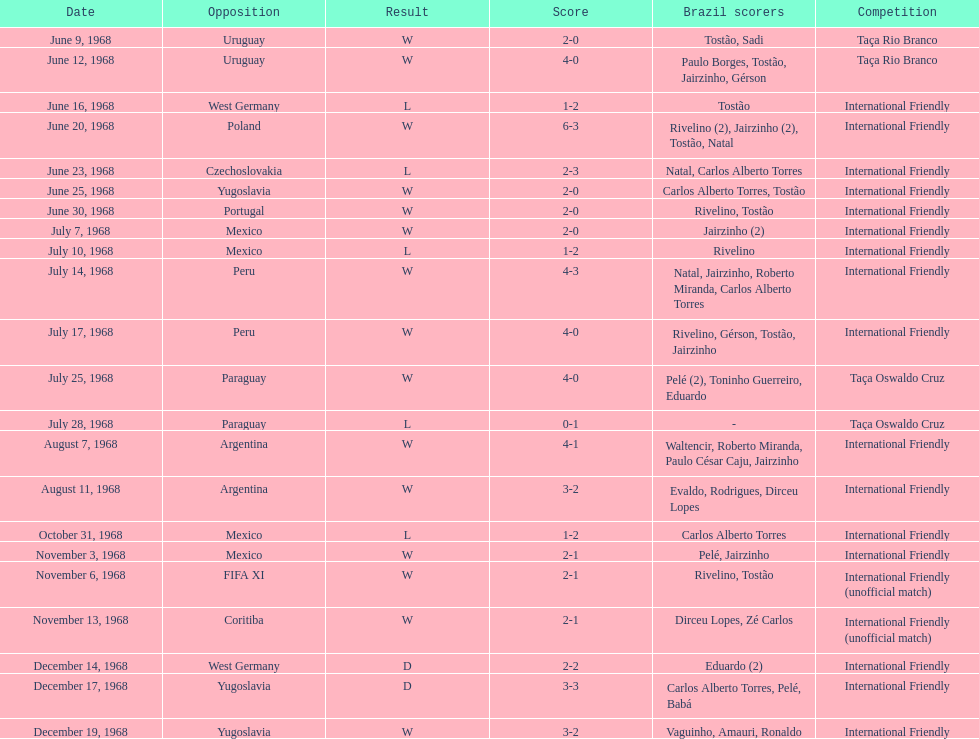What was the first tournament that brazil participated in? Taça Rio Branco. I'm looking to parse the entire table for insights. Could you assist me with that? {'header': ['Date', 'Opposition', 'Result', 'Score', 'Brazil scorers', 'Competition'], 'rows': [['June 9, 1968', 'Uruguay', 'W', '2-0', 'Tostão, Sadi', 'Taça Rio Branco'], ['June 12, 1968', 'Uruguay', 'W', '4-0', 'Paulo Borges, Tostão, Jairzinho, Gérson', 'Taça Rio Branco'], ['June 16, 1968', 'West Germany', 'L', '1-2', 'Tostão', 'International Friendly'], ['June 20, 1968', 'Poland', 'W', '6-3', 'Rivelino (2), Jairzinho (2), Tostão, Natal', 'International Friendly'], ['June 23, 1968', 'Czechoslovakia', 'L', '2-3', 'Natal, Carlos Alberto Torres', 'International Friendly'], ['June 25, 1968', 'Yugoslavia', 'W', '2-0', 'Carlos Alberto Torres, Tostão', 'International Friendly'], ['June 30, 1968', 'Portugal', 'W', '2-0', 'Rivelino, Tostão', 'International Friendly'], ['July 7, 1968', 'Mexico', 'W', '2-0', 'Jairzinho (2)', 'International Friendly'], ['July 10, 1968', 'Mexico', 'L', '1-2', 'Rivelino', 'International Friendly'], ['July 14, 1968', 'Peru', 'W', '4-3', 'Natal, Jairzinho, Roberto Miranda, Carlos Alberto Torres', 'International Friendly'], ['July 17, 1968', 'Peru', 'W', '4-0', 'Rivelino, Gérson, Tostão, Jairzinho', 'International Friendly'], ['July 25, 1968', 'Paraguay', 'W', '4-0', 'Pelé (2), Toninho Guerreiro, Eduardo', 'Taça Oswaldo Cruz'], ['July 28, 1968', 'Paraguay', 'L', '0-1', '-', 'Taça Oswaldo Cruz'], ['August 7, 1968', 'Argentina', 'W', '4-1', 'Waltencir, Roberto Miranda, Paulo César Caju, Jairzinho', 'International Friendly'], ['August 11, 1968', 'Argentina', 'W', '3-2', 'Evaldo, Rodrigues, Dirceu Lopes', 'International Friendly'], ['October 31, 1968', 'Mexico', 'L', '1-2', 'Carlos Alberto Torres', 'International Friendly'], ['November 3, 1968', 'Mexico', 'W', '2-1', 'Pelé, Jairzinho', 'International Friendly'], ['November 6, 1968', 'FIFA XI', 'W', '2-1', 'Rivelino, Tostão', 'International Friendly (unofficial match)'], ['November 13, 1968', 'Coritiba', 'W', '2-1', 'Dirceu Lopes, Zé Carlos', 'International Friendly (unofficial match)'], ['December 14, 1968', 'West Germany', 'D', '2-2', 'Eduardo (2)', 'International Friendly'], ['December 17, 1968', 'Yugoslavia', 'D', '3-3', 'Carlos Alberto Torres, Pelé, Babá', 'International Friendly'], ['December 19, 1968', 'Yugoslavia', 'W', '3-2', 'Vaguinho, Amauri, Ronaldo', 'International Friendly']]} 